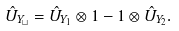Convert formula to latex. <formula><loc_0><loc_0><loc_500><loc_500>\hat { U } _ { Y _ { \sqcup } } = \hat { U } _ { Y _ { 1 } } \otimes 1 - 1 \otimes \hat { U } _ { Y _ { 2 } } .</formula> 